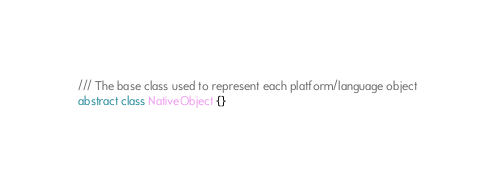Convert code to text. <code><loc_0><loc_0><loc_500><loc_500><_Dart_>/// The base class used to represent each platform/language object
abstract class NativeObject {}
</code> 